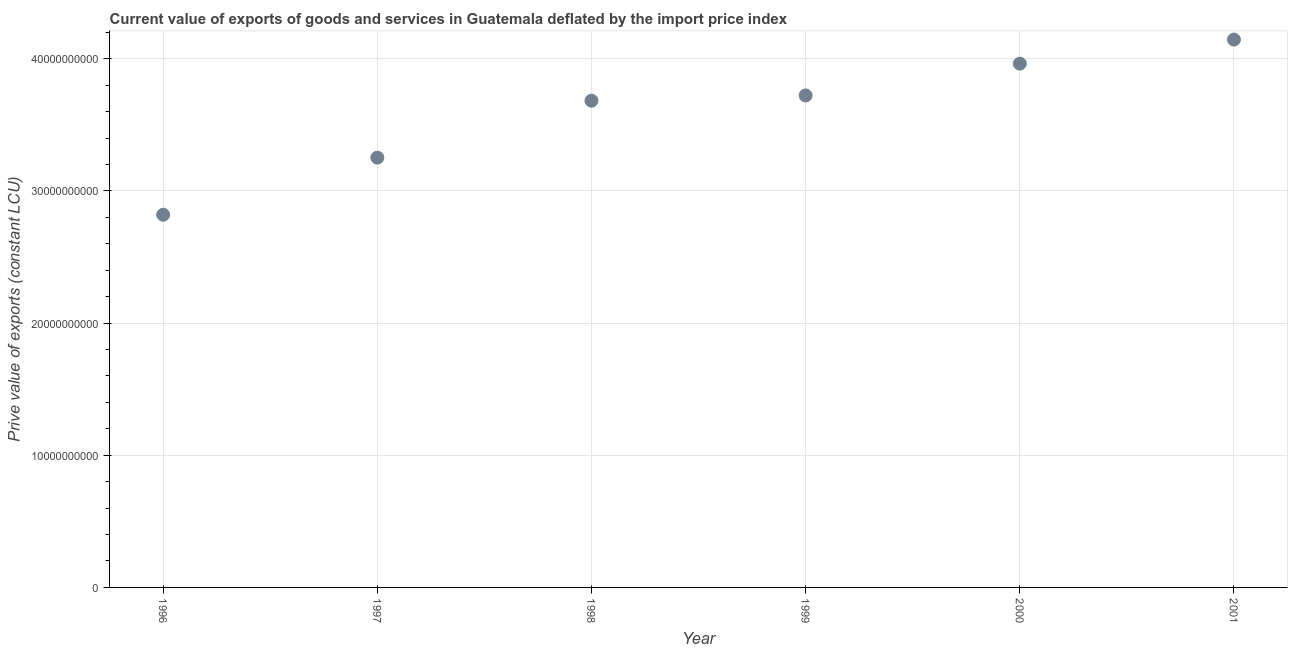What is the price value of exports in 2001?
Keep it short and to the point. 4.15e+1. Across all years, what is the maximum price value of exports?
Ensure brevity in your answer.  4.15e+1. Across all years, what is the minimum price value of exports?
Provide a succinct answer. 2.82e+1. In which year was the price value of exports maximum?
Make the answer very short. 2001. What is the sum of the price value of exports?
Your response must be concise. 2.16e+11. What is the difference between the price value of exports in 1998 and 1999?
Offer a very short reply. -3.98e+08. What is the average price value of exports per year?
Provide a short and direct response. 3.60e+1. What is the median price value of exports?
Make the answer very short. 3.70e+1. Do a majority of the years between 2000 and 1998 (inclusive) have price value of exports greater than 24000000000 LCU?
Your answer should be compact. No. What is the ratio of the price value of exports in 1996 to that in 2000?
Keep it short and to the point. 0.71. Is the price value of exports in 2000 less than that in 2001?
Your answer should be compact. Yes. What is the difference between the highest and the second highest price value of exports?
Provide a short and direct response. 1.82e+09. Is the sum of the price value of exports in 1997 and 2000 greater than the maximum price value of exports across all years?
Make the answer very short. Yes. What is the difference between the highest and the lowest price value of exports?
Your answer should be very brief. 1.33e+1. What is the difference between two consecutive major ticks on the Y-axis?
Give a very brief answer. 1.00e+1. Are the values on the major ticks of Y-axis written in scientific E-notation?
Provide a short and direct response. No. Does the graph contain any zero values?
Provide a succinct answer. No. Does the graph contain grids?
Your response must be concise. Yes. What is the title of the graph?
Ensure brevity in your answer.  Current value of exports of goods and services in Guatemala deflated by the import price index. What is the label or title of the X-axis?
Your answer should be very brief. Year. What is the label or title of the Y-axis?
Provide a succinct answer. Prive value of exports (constant LCU). What is the Prive value of exports (constant LCU) in 1996?
Offer a very short reply. 2.82e+1. What is the Prive value of exports (constant LCU) in 1997?
Give a very brief answer. 3.25e+1. What is the Prive value of exports (constant LCU) in 1998?
Provide a succinct answer. 3.68e+1. What is the Prive value of exports (constant LCU) in 1999?
Ensure brevity in your answer.  3.72e+1. What is the Prive value of exports (constant LCU) in 2000?
Provide a short and direct response. 3.96e+1. What is the Prive value of exports (constant LCU) in 2001?
Offer a very short reply. 4.15e+1. What is the difference between the Prive value of exports (constant LCU) in 1996 and 1997?
Make the answer very short. -4.32e+09. What is the difference between the Prive value of exports (constant LCU) in 1996 and 1998?
Your response must be concise. -8.63e+09. What is the difference between the Prive value of exports (constant LCU) in 1996 and 1999?
Provide a short and direct response. -9.02e+09. What is the difference between the Prive value of exports (constant LCU) in 1996 and 2000?
Your answer should be compact. -1.14e+1. What is the difference between the Prive value of exports (constant LCU) in 1996 and 2001?
Your response must be concise. -1.33e+1. What is the difference between the Prive value of exports (constant LCU) in 1997 and 1998?
Ensure brevity in your answer.  -4.31e+09. What is the difference between the Prive value of exports (constant LCU) in 1997 and 1999?
Offer a terse response. -4.71e+09. What is the difference between the Prive value of exports (constant LCU) in 1997 and 2000?
Provide a succinct answer. -7.11e+09. What is the difference between the Prive value of exports (constant LCU) in 1997 and 2001?
Provide a succinct answer. -8.93e+09. What is the difference between the Prive value of exports (constant LCU) in 1998 and 1999?
Offer a very short reply. -3.98e+08. What is the difference between the Prive value of exports (constant LCU) in 1998 and 2000?
Provide a short and direct response. -2.81e+09. What is the difference between the Prive value of exports (constant LCU) in 1998 and 2001?
Keep it short and to the point. -4.63e+09. What is the difference between the Prive value of exports (constant LCU) in 1999 and 2000?
Provide a short and direct response. -2.41e+09. What is the difference between the Prive value of exports (constant LCU) in 1999 and 2001?
Your answer should be very brief. -4.23e+09. What is the difference between the Prive value of exports (constant LCU) in 2000 and 2001?
Your response must be concise. -1.82e+09. What is the ratio of the Prive value of exports (constant LCU) in 1996 to that in 1997?
Provide a short and direct response. 0.87. What is the ratio of the Prive value of exports (constant LCU) in 1996 to that in 1998?
Make the answer very short. 0.77. What is the ratio of the Prive value of exports (constant LCU) in 1996 to that in 1999?
Keep it short and to the point. 0.76. What is the ratio of the Prive value of exports (constant LCU) in 1996 to that in 2000?
Your response must be concise. 0.71. What is the ratio of the Prive value of exports (constant LCU) in 1996 to that in 2001?
Ensure brevity in your answer.  0.68. What is the ratio of the Prive value of exports (constant LCU) in 1997 to that in 1998?
Give a very brief answer. 0.88. What is the ratio of the Prive value of exports (constant LCU) in 1997 to that in 1999?
Keep it short and to the point. 0.87. What is the ratio of the Prive value of exports (constant LCU) in 1997 to that in 2000?
Your answer should be very brief. 0.82. What is the ratio of the Prive value of exports (constant LCU) in 1997 to that in 2001?
Offer a terse response. 0.78. What is the ratio of the Prive value of exports (constant LCU) in 1998 to that in 2000?
Give a very brief answer. 0.93. What is the ratio of the Prive value of exports (constant LCU) in 1998 to that in 2001?
Offer a terse response. 0.89. What is the ratio of the Prive value of exports (constant LCU) in 1999 to that in 2000?
Provide a short and direct response. 0.94. What is the ratio of the Prive value of exports (constant LCU) in 1999 to that in 2001?
Give a very brief answer. 0.9. What is the ratio of the Prive value of exports (constant LCU) in 2000 to that in 2001?
Ensure brevity in your answer.  0.96. 